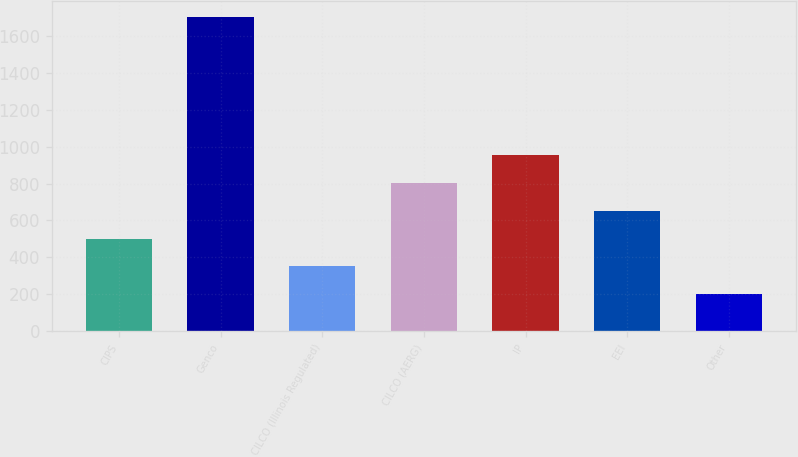Convert chart to OTSL. <chart><loc_0><loc_0><loc_500><loc_500><bar_chart><fcel>CIPS<fcel>Genco<fcel>CILCO (Illinois Regulated)<fcel>CILCO (AERG)<fcel>IP<fcel>EEI<fcel>Other<nl><fcel>501<fcel>1705<fcel>350.5<fcel>802<fcel>952.5<fcel>651.5<fcel>200<nl></chart> 